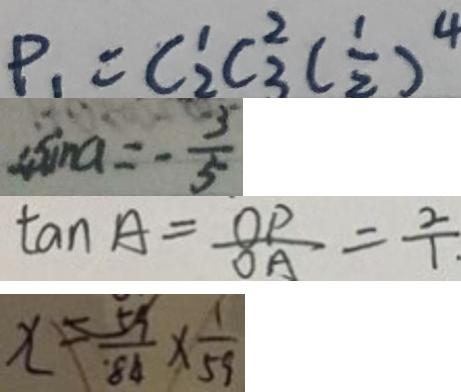Convert formula to latex. <formula><loc_0><loc_0><loc_500><loc_500>P _ { 1 } = C ^ { 1 } _ { 2 } C _ { 3 } ^ { 2 } ( \frac { 1 } { 2 } ) ^ { 4 } 
 4 \sin a = - \frac { 5 } { 5 } 
 \tan A = \frac { O P } { O A } = \frac { 2 } { 1 } 
 x = \frac { 5 9 } { 8 4 } \times \frac { 1 } { 5 9 }</formula> 